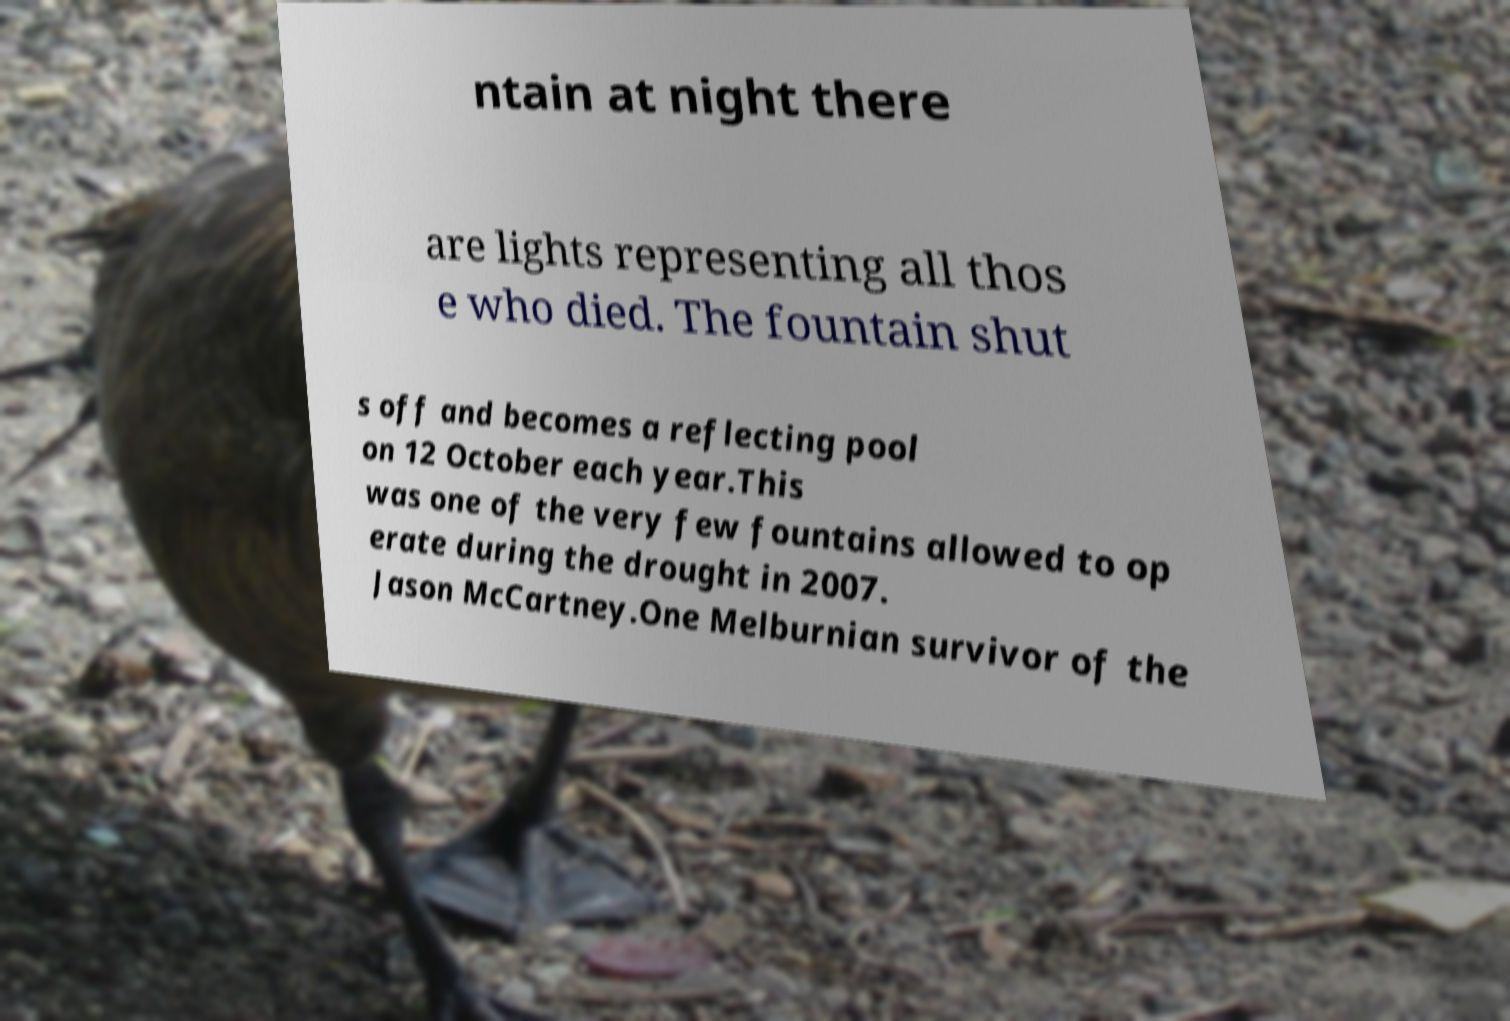Can you read and provide the text displayed in the image?This photo seems to have some interesting text. Can you extract and type it out for me? ntain at night there are lights representing all thos e who died. The fountain shut s off and becomes a reflecting pool on 12 October each year.This was one of the very few fountains allowed to op erate during the drought in 2007. Jason McCartney.One Melburnian survivor of the 